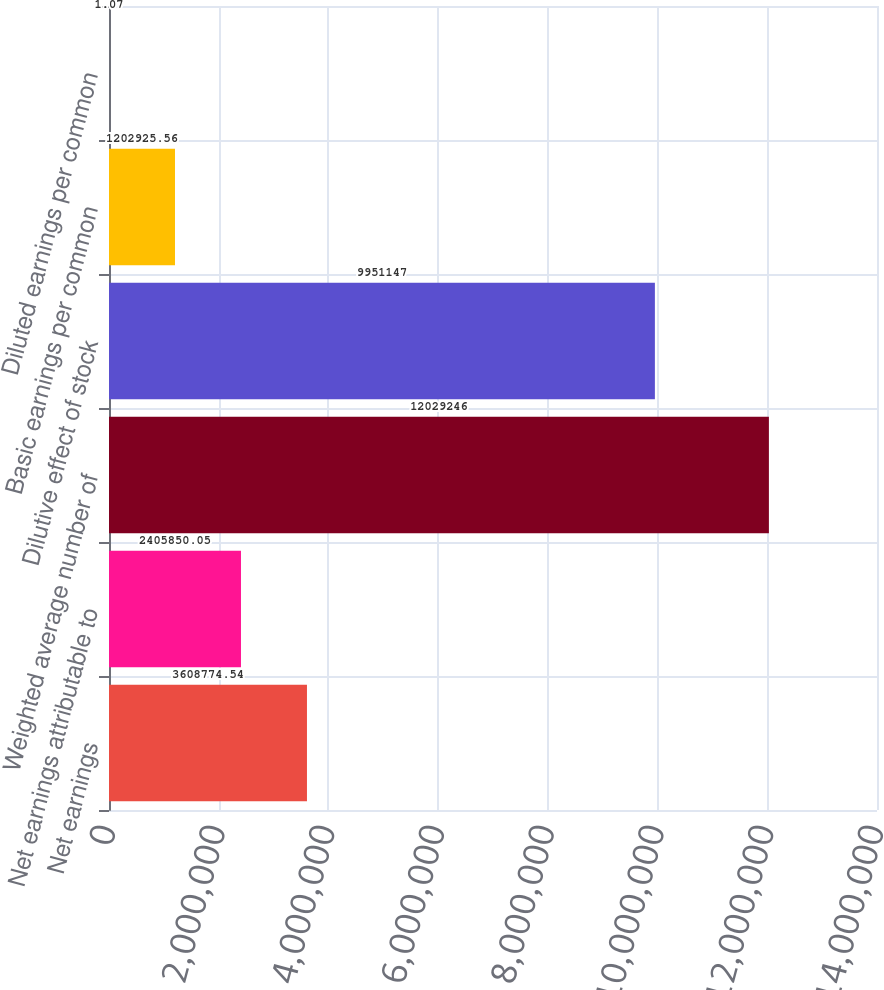Convert chart to OTSL. <chart><loc_0><loc_0><loc_500><loc_500><bar_chart><fcel>Net earnings<fcel>Net earnings attributable to<fcel>Weighted average number of<fcel>Dilutive effect of stock<fcel>Basic earnings per common<fcel>Diluted earnings per common<nl><fcel>3.60877e+06<fcel>2.40585e+06<fcel>1.20292e+07<fcel>9.95115e+06<fcel>1.20293e+06<fcel>1.07<nl></chart> 